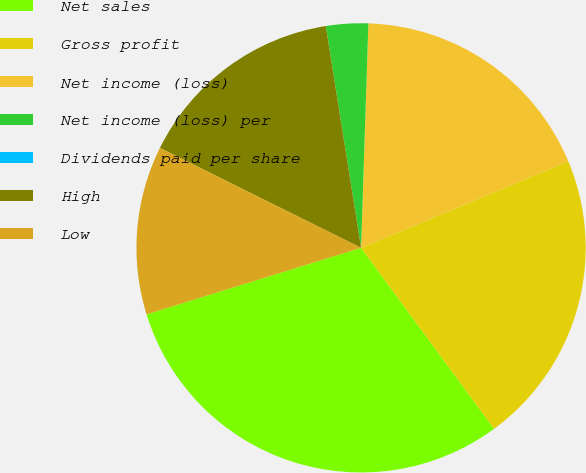<chart> <loc_0><loc_0><loc_500><loc_500><pie_chart><fcel>Net sales<fcel>Gross profit<fcel>Net income (loss)<fcel>Net income (loss) per<fcel>Dividends paid per share<fcel>High<fcel>Low<nl><fcel>30.3%<fcel>21.21%<fcel>18.18%<fcel>3.03%<fcel>0.0%<fcel>15.15%<fcel>12.12%<nl></chart> 